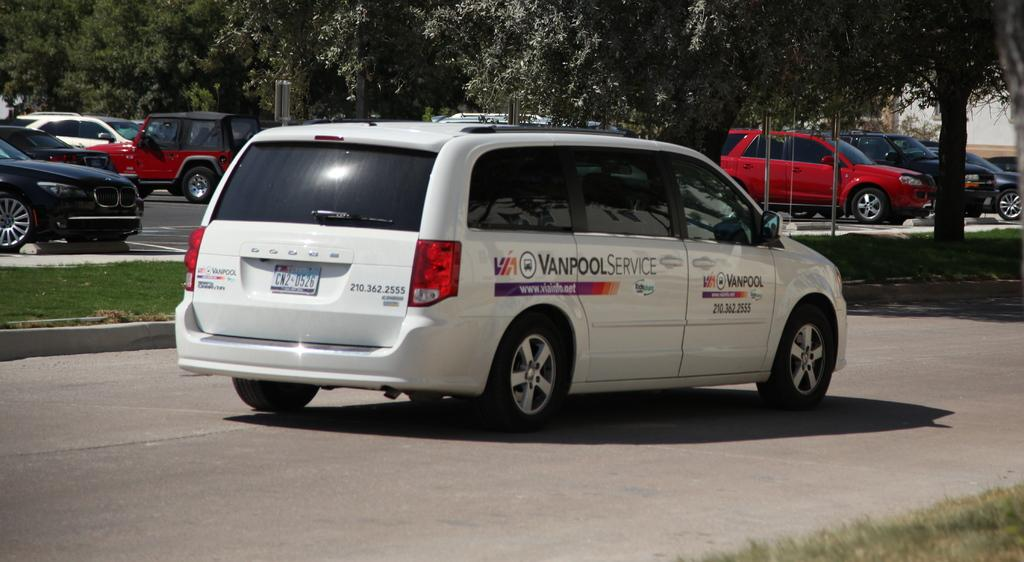What types of objects are present in the image? There are vehicles in the image. Can you describe the color of the front vehicle? The front vehicle is white. What can be seen in the background of the image? There are trees and a building in the background of the image. What is the color of the trees? The trees are green. Can you describe the color of the building in the background? The building is white. Can you tell me how many jellyfish are swimming near the building in the image? There are no jellyfish present in the image; it features vehicles, trees, and a building. What type of sign is visible on the front vehicle in the image? There is no sign visible on the front vehicle in the image. 